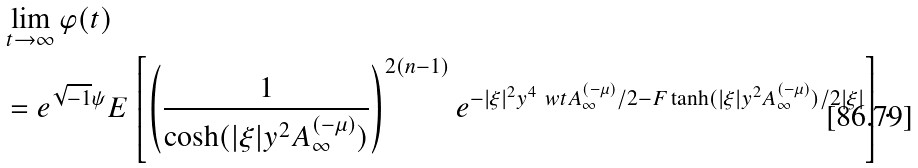<formula> <loc_0><loc_0><loc_500><loc_500>& \lim _ { t \to \infty } \varphi ( t ) \\ & = e ^ { \sqrt { - 1 } \psi } E \left [ \left ( \frac { 1 } { \cosh ( | \xi | y ^ { 2 } A ^ { ( - \mu ) } _ { \infty } ) } \right ) ^ { 2 ( n - 1 ) } e ^ { - | \xi | ^ { 2 } y ^ { 4 } \ w t { A } ^ { ( - \mu ) } _ { \infty } / 2 - F \tanh ( | \xi | y ^ { 2 } A ^ { ( - \mu ) } _ { \infty } ) / 2 | \xi | } \right ] .</formula> 